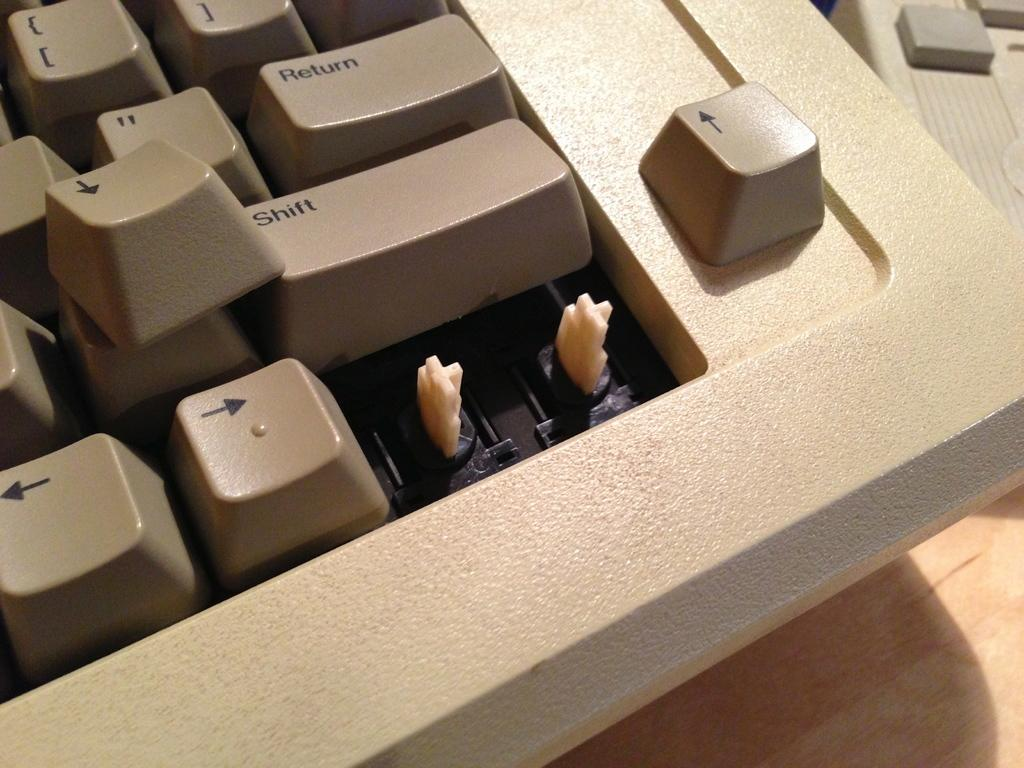<image>
Present a compact description of the photo's key features. the word shift is on one of the keys on the keyboard 